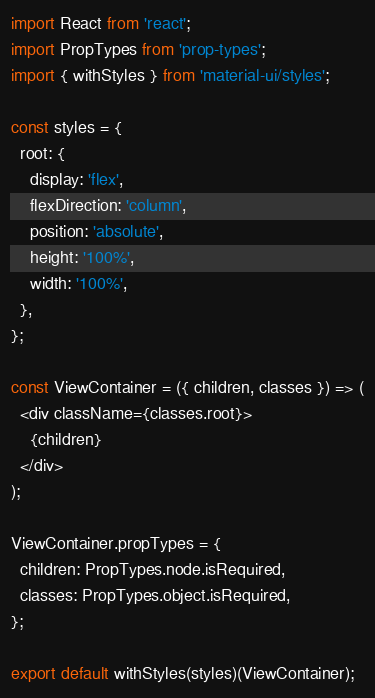Convert code to text. <code><loc_0><loc_0><loc_500><loc_500><_JavaScript_>import React from 'react';
import PropTypes from 'prop-types';
import { withStyles } from 'material-ui/styles';

const styles = {
  root: {
    display: 'flex',
    flexDirection: 'column',
    position: 'absolute',
    height: '100%',
    width: '100%',
  },
};

const ViewContainer = ({ children, classes }) => (
  <div className={classes.root}>
    {children}
  </div>
);

ViewContainer.propTypes = {
  children: PropTypes.node.isRequired,
  classes: PropTypes.object.isRequired,
};

export default withStyles(styles)(ViewContainer);
</code> 